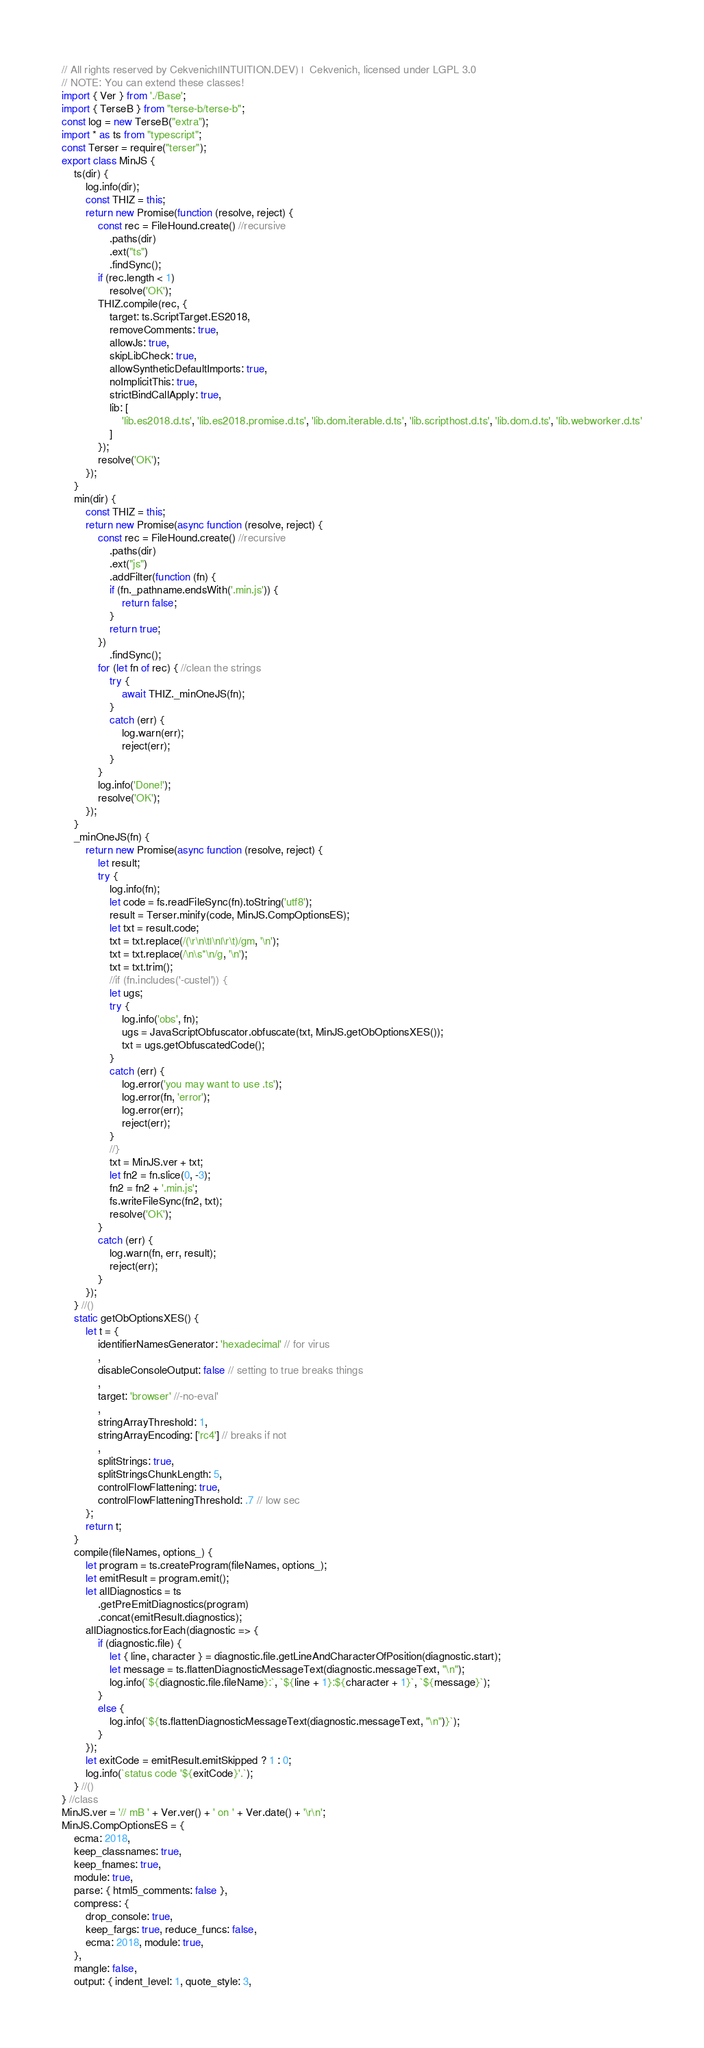Convert code to text. <code><loc_0><loc_0><loc_500><loc_500><_JavaScript_>// All rights reserved by Cekvenich|INTUITION.DEV) |  Cekvenich, licensed under LGPL 3.0
// NOTE: You can extend these classes!
import { Ver } from './Base';
import { TerseB } from "terse-b/terse-b";
const log = new TerseB("extra");
import * as ts from "typescript";
const Terser = require("terser");
export class MinJS {
    ts(dir) {
        log.info(dir);
        const THIZ = this;
        return new Promise(function (resolve, reject) {
            const rec = FileHound.create() //recursive
                .paths(dir)
                .ext("ts")
                .findSync();
            if (rec.length < 1)
                resolve('OK');
            THIZ.compile(rec, {
                target: ts.ScriptTarget.ES2018,
                removeComments: true,
                allowJs: true,
                skipLibCheck: true,
                allowSyntheticDefaultImports: true,
                noImplicitThis: true,
                strictBindCallApply: true,
                lib: [
                    'lib.es2018.d.ts', 'lib.es2018.promise.d.ts', 'lib.dom.iterable.d.ts', 'lib.scripthost.d.ts', 'lib.dom.d.ts', 'lib.webworker.d.ts'
                ]
            });
            resolve('OK');
        });
    }
    min(dir) {
        const THIZ = this;
        return new Promise(async function (resolve, reject) {
            const rec = FileHound.create() //recursive
                .paths(dir)
                .ext("js")
                .addFilter(function (fn) {
                if (fn._pathname.endsWith('.min.js')) {
                    return false;
                }
                return true;
            })
                .findSync();
            for (let fn of rec) { //clean the strings
                try {
                    await THIZ._minOneJS(fn);
                }
                catch (err) {
                    log.warn(err);
                    reject(err);
                }
            }
            log.info('Done!');
            resolve('OK');
        });
    }
    _minOneJS(fn) {
        return new Promise(async function (resolve, reject) {
            let result;
            try {
                log.info(fn);
                let code = fs.readFileSync(fn).toString('utf8');
                result = Terser.minify(code, MinJS.CompOptionsES);
                let txt = result.code;
                txt = txt.replace(/(\r\n\t|\n|\r\t)/gm, '\n');
                txt = txt.replace(/\n\s*\n/g, '\n');
                txt = txt.trim();
                //if (fn.includes('-custel')) {
                let ugs;
                try {
                    log.info('obs', fn);
                    ugs = JavaScriptObfuscator.obfuscate(txt, MinJS.getObOptionsXES());
                    txt = ugs.getObfuscatedCode();
                }
                catch (err) {
                    log.error('you may want to use .ts');
                    log.error(fn, 'error');
                    log.error(err);
                    reject(err);
                }
                //}
                txt = MinJS.ver + txt;
                let fn2 = fn.slice(0, -3);
                fn2 = fn2 + '.min.js';
                fs.writeFileSync(fn2, txt);
                resolve('OK');
            }
            catch (err) {
                log.warn(fn, err, result);
                reject(err);
            }
        });
    } //()
    static getObOptionsXES() {
        let t = {
            identifierNamesGenerator: 'hexadecimal' // for virus
            ,
            disableConsoleOutput: false // setting to true breaks things
            ,
            target: 'browser' //-no-eval'
            ,
            stringArrayThreshold: 1,
            stringArrayEncoding: ['rc4'] // breaks if not
            ,
            splitStrings: true,
            splitStringsChunkLength: 5,
            controlFlowFlattening: true,
            controlFlowFlatteningThreshold: .7 // low sec
        };
        return t;
    }
    compile(fileNames, options_) {
        let program = ts.createProgram(fileNames, options_);
        let emitResult = program.emit();
        let allDiagnostics = ts
            .getPreEmitDiagnostics(program)
            .concat(emitResult.diagnostics);
        allDiagnostics.forEach(diagnostic => {
            if (diagnostic.file) {
                let { line, character } = diagnostic.file.getLineAndCharacterOfPosition(diagnostic.start);
                let message = ts.flattenDiagnosticMessageText(diagnostic.messageText, "\n");
                log.info(`${diagnostic.file.fileName}:`, `${line + 1}:${character + 1}`, `${message}`);
            }
            else {
                log.info(`${ts.flattenDiagnosticMessageText(diagnostic.messageText, "\n")}`);
            }
        });
        let exitCode = emitResult.emitSkipped ? 1 : 0;
        log.info(`status code '${exitCode}'.`);
    } //()
} //class
MinJS.ver = '// mB ' + Ver.ver() + ' on ' + Ver.date() + '\r\n';
MinJS.CompOptionsES = {
    ecma: 2018,
    keep_classnames: true,
    keep_fnames: true,
    module: true,
    parse: { html5_comments: false },
    compress: {
        drop_console: true,
        keep_fargs: true, reduce_funcs: false,
        ecma: 2018, module: true,
    },
    mangle: false,
    output: { indent_level: 1, quote_style: 3,</code> 